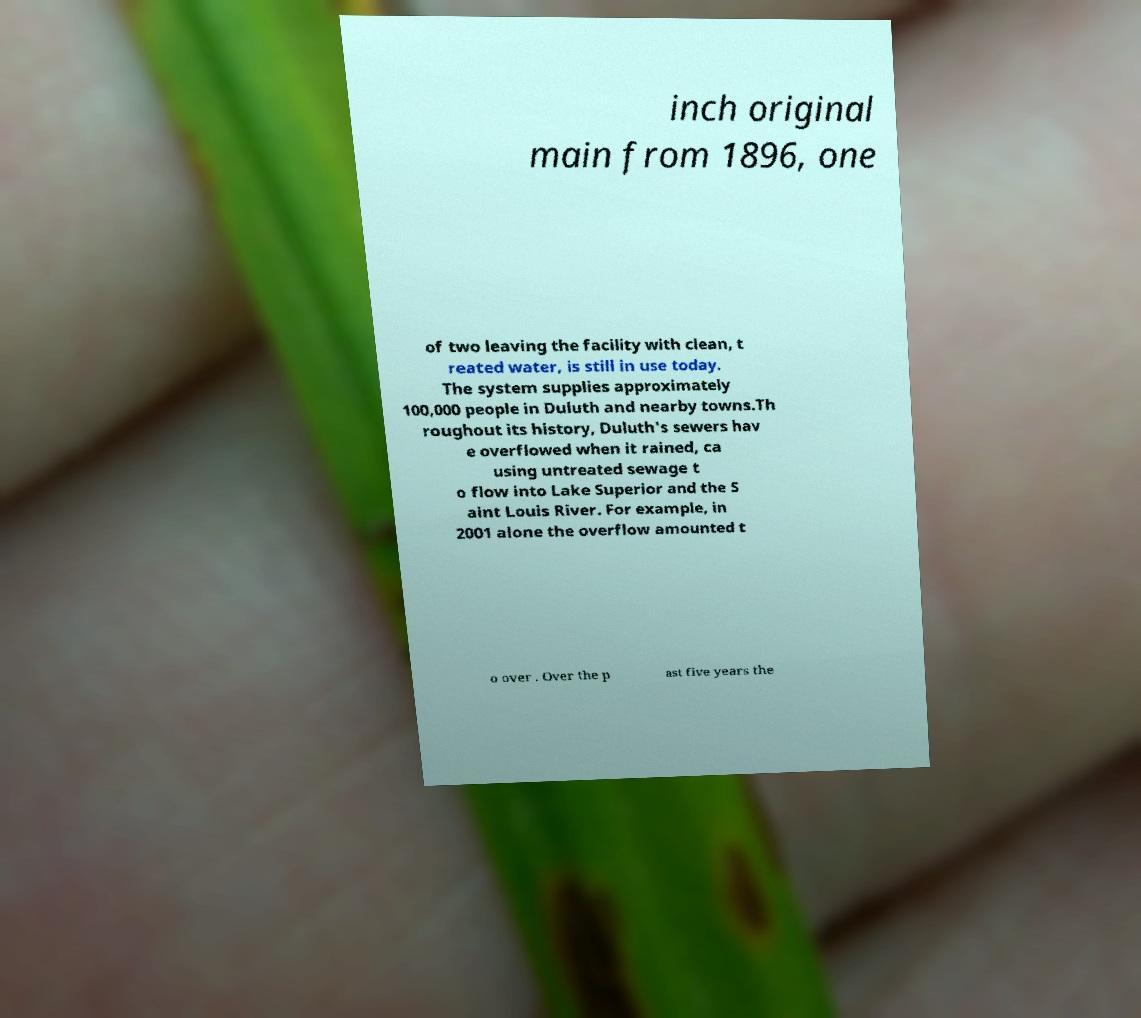Please identify and transcribe the text found in this image. inch original main from 1896, one of two leaving the facility with clean, t reated water, is still in use today. The system supplies approximately 100,000 people in Duluth and nearby towns.Th roughout its history, Duluth's sewers hav e overflowed when it rained, ca using untreated sewage t o flow into Lake Superior and the S aint Louis River. For example, in 2001 alone the overflow amounted t o over . Over the p ast five years the 